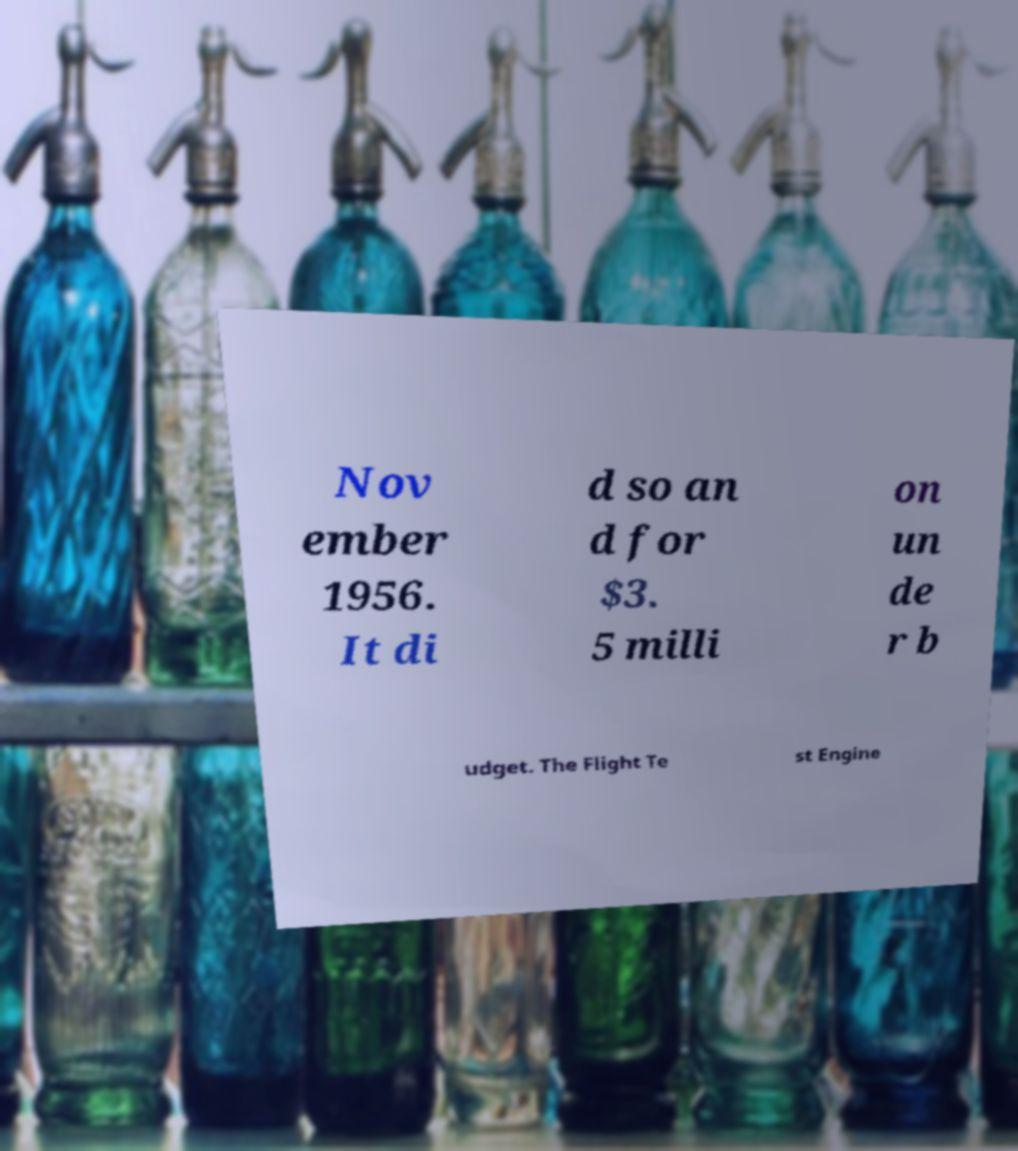Could you extract and type out the text from this image? Nov ember 1956. It di d so an d for $3. 5 milli on un de r b udget. The Flight Te st Engine 